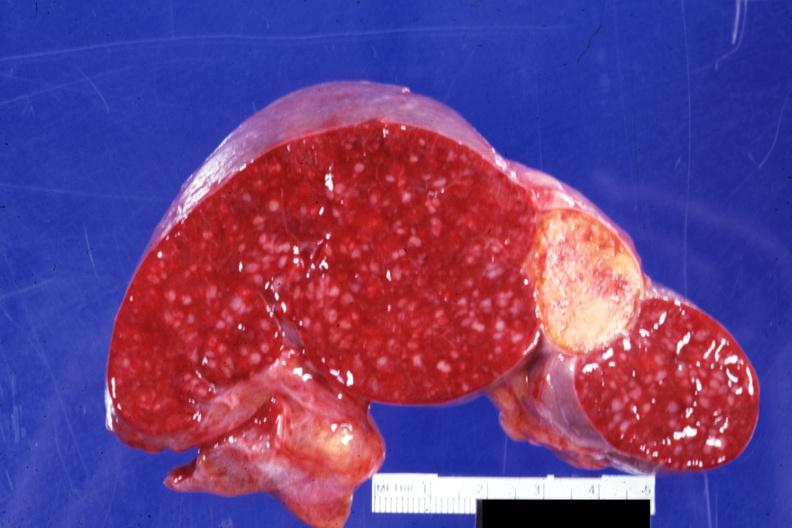s spina bifida present?
Answer the question using a single word or phrase. No 